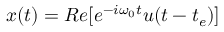Convert formula to latex. <formula><loc_0><loc_0><loc_500><loc_500>x ( t ) = R e [ e ^ { - i \omega _ { 0 } t } u ( t - t _ { e } ) ]</formula> 